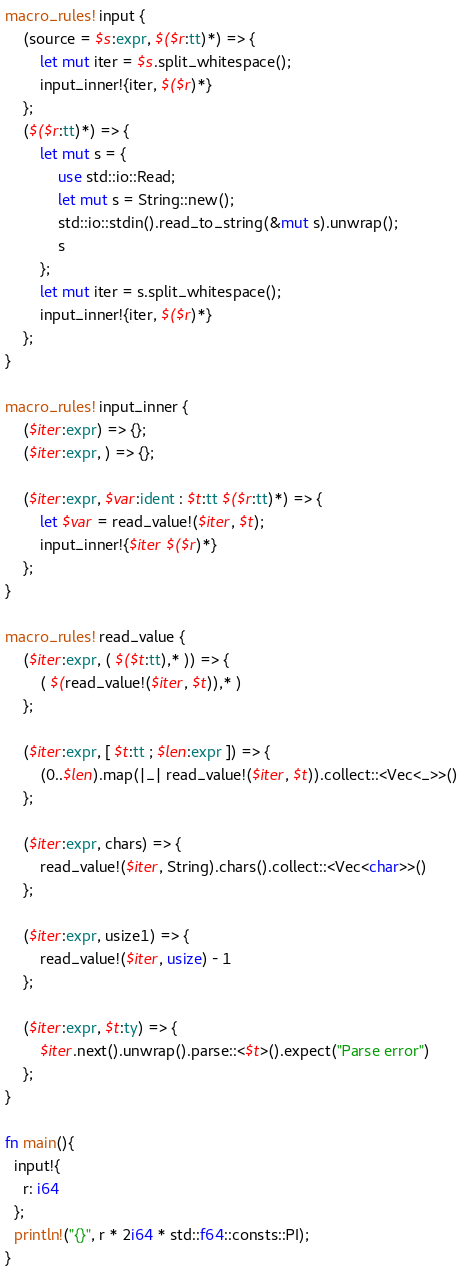Convert code to text. <code><loc_0><loc_0><loc_500><loc_500><_Rust_>macro_rules! input {
    (source = $s:expr, $($r:tt)*) => {
        let mut iter = $s.split_whitespace();
        input_inner!{iter, $($r)*}
    };
    ($($r:tt)*) => {
        let mut s = {
            use std::io::Read;
            let mut s = String::new();
            std::io::stdin().read_to_string(&mut s).unwrap();
            s
        };
        let mut iter = s.split_whitespace();
        input_inner!{iter, $($r)*}
    };
}
 
macro_rules! input_inner {
    ($iter:expr) => {};
    ($iter:expr, ) => {};
 
    ($iter:expr, $var:ident : $t:tt $($r:tt)*) => {
        let $var = read_value!($iter, $t);
        input_inner!{$iter $($r)*}
    };
}
 
macro_rules! read_value {
    ($iter:expr, ( $($t:tt),* )) => {
        ( $(read_value!($iter, $t)),* )
    };
 
    ($iter:expr, [ $t:tt ; $len:expr ]) => {
        (0..$len).map(|_| read_value!($iter, $t)).collect::<Vec<_>>()
    };
 
    ($iter:expr, chars) => {
        read_value!($iter, String).chars().collect::<Vec<char>>()
    };
 
    ($iter:expr, usize1) => {
        read_value!($iter, usize) - 1
    };
 
    ($iter:expr, $t:ty) => {
        $iter.next().unwrap().parse::<$t>().expect("Parse error")
    };
}

fn main(){
  input!{
    r: i64
  };
  println!("{}", r * 2i64 * std::f64::consts::PI);
}
</code> 